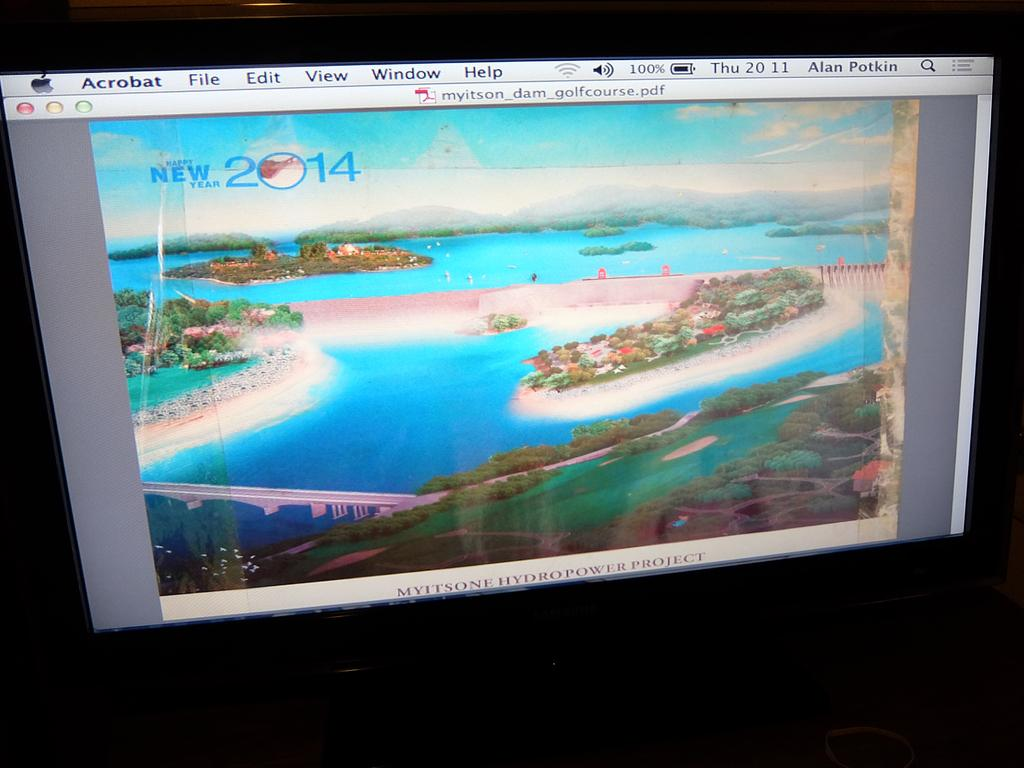<image>
Summarize the visual content of the image. acrobat is on the television screen with a nice image 